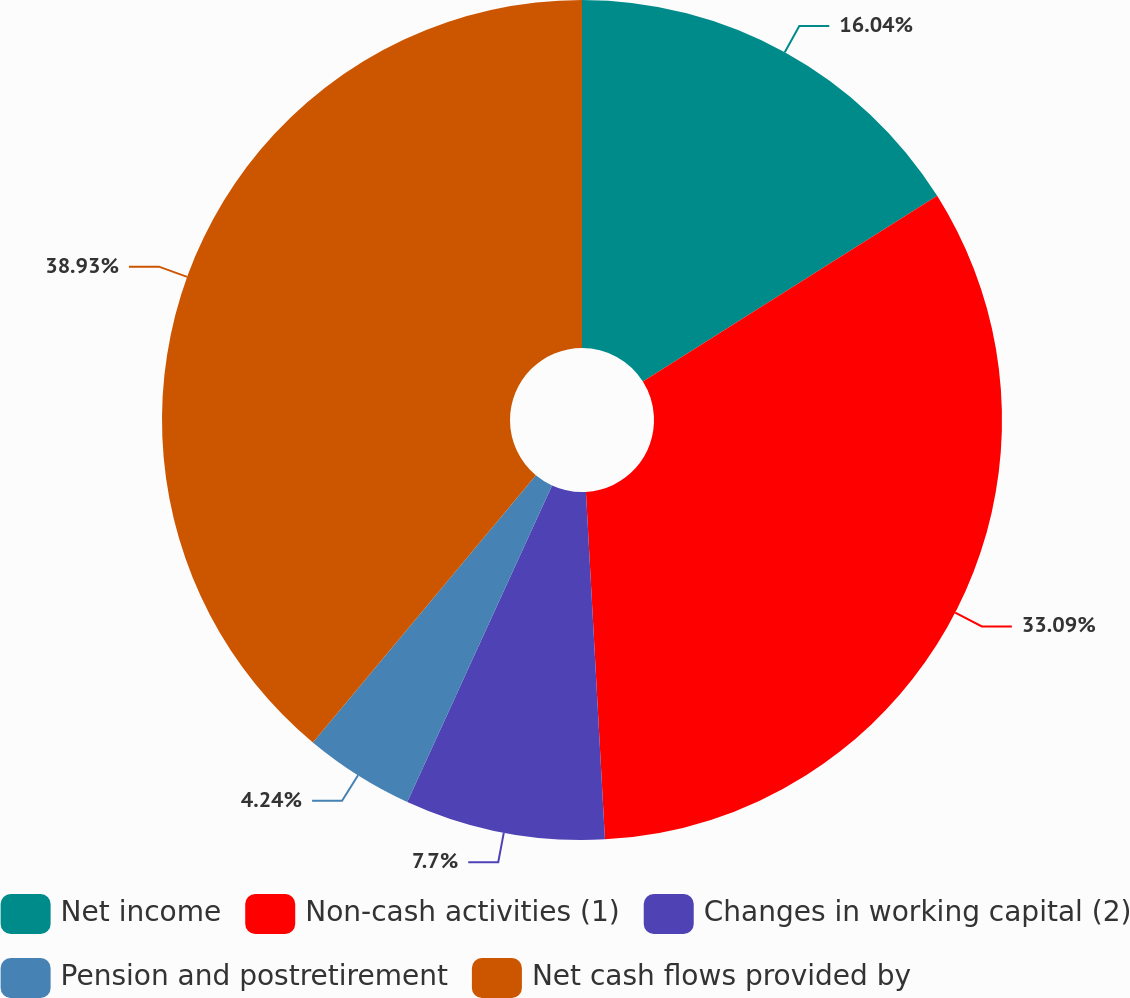<chart> <loc_0><loc_0><loc_500><loc_500><pie_chart><fcel>Net income<fcel>Non-cash activities (1)<fcel>Changes in working capital (2)<fcel>Pension and postretirement<fcel>Net cash flows provided by<nl><fcel>16.04%<fcel>33.09%<fcel>7.7%<fcel>4.24%<fcel>38.93%<nl></chart> 